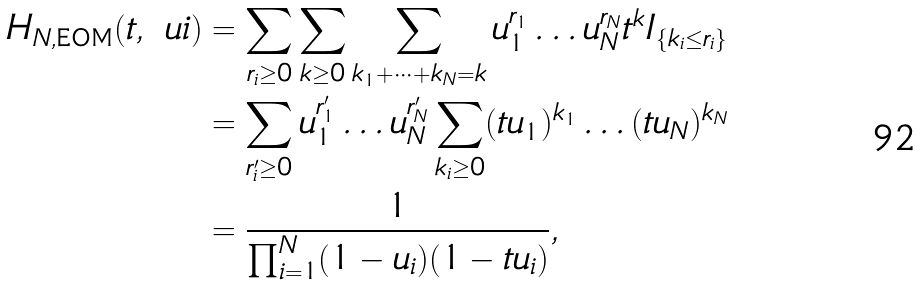Convert formula to latex. <formula><loc_0><loc_0><loc_500><loc_500>H _ { N , \text {EOM} } ( t , \ u i ) & = \sum _ { r _ { i } \geq 0 } \sum _ { k \geq 0 } \sum _ { k _ { 1 } + \dots + k _ { N } = k } u _ { 1 } ^ { r _ { 1 } } \dots u _ { N } ^ { r _ { N } } t ^ { k } I _ { \{ k _ { i } \leq r _ { i } \} } \\ & = \sum _ { r ^ { \prime } _ { i } \geq 0 } u _ { 1 } ^ { r ^ { \prime } _ { 1 } } \dots u _ { N } ^ { r ^ { \prime } _ { N } } \sum _ { k _ { i } \geq 0 } ( t u _ { 1 } ) ^ { k _ { 1 } } \dots ( t u _ { N } ) ^ { k _ { N } } \\ & = \frac { 1 } { \prod _ { i = 1 } ^ { N } ( 1 - u _ { i } ) ( 1 - t u _ { i } ) } ,</formula> 